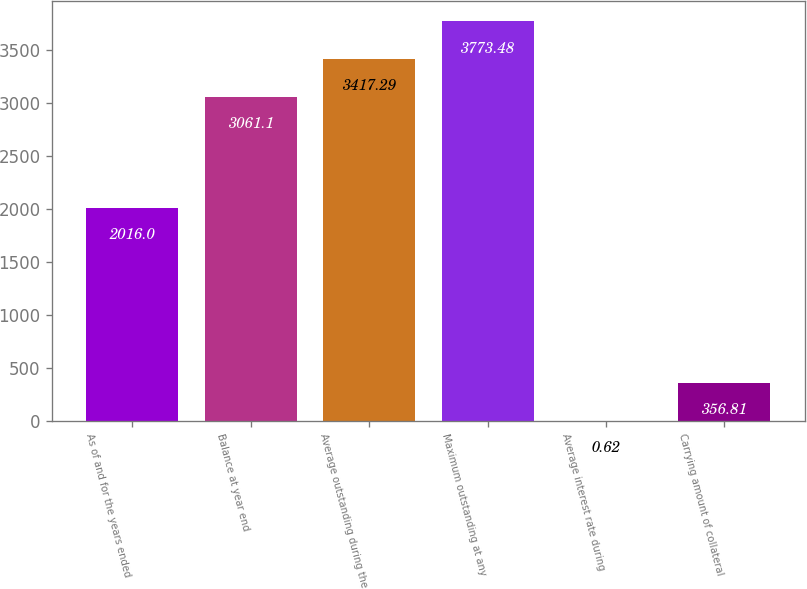Convert chart. <chart><loc_0><loc_0><loc_500><loc_500><bar_chart><fcel>As of and for the years ended<fcel>Balance at year end<fcel>Average outstanding during the<fcel>Maximum outstanding at any<fcel>Average interest rate during<fcel>Carrying amount of collateral<nl><fcel>2016<fcel>3061.1<fcel>3417.29<fcel>3773.48<fcel>0.62<fcel>356.81<nl></chart> 